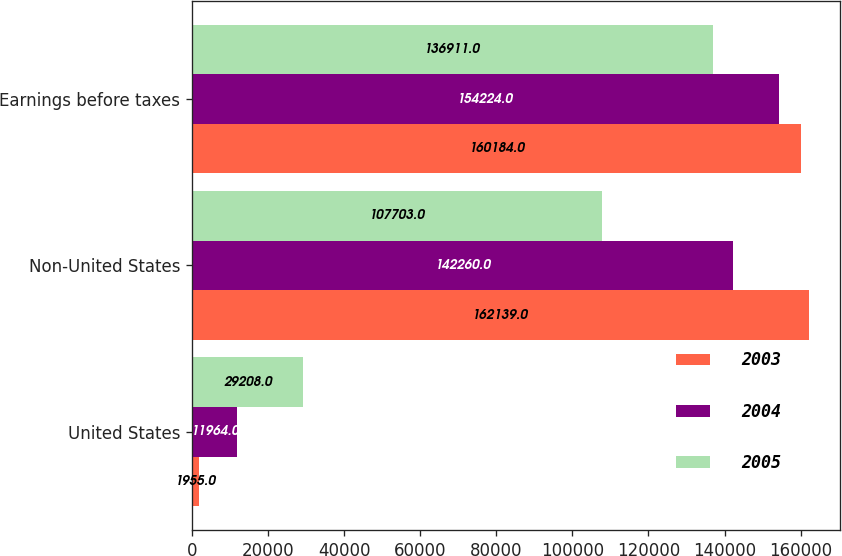Convert chart. <chart><loc_0><loc_0><loc_500><loc_500><stacked_bar_chart><ecel><fcel>United States<fcel>Non-United States<fcel>Earnings before taxes<nl><fcel>2003<fcel>1955<fcel>162139<fcel>160184<nl><fcel>2004<fcel>11964<fcel>142260<fcel>154224<nl><fcel>2005<fcel>29208<fcel>107703<fcel>136911<nl></chart> 